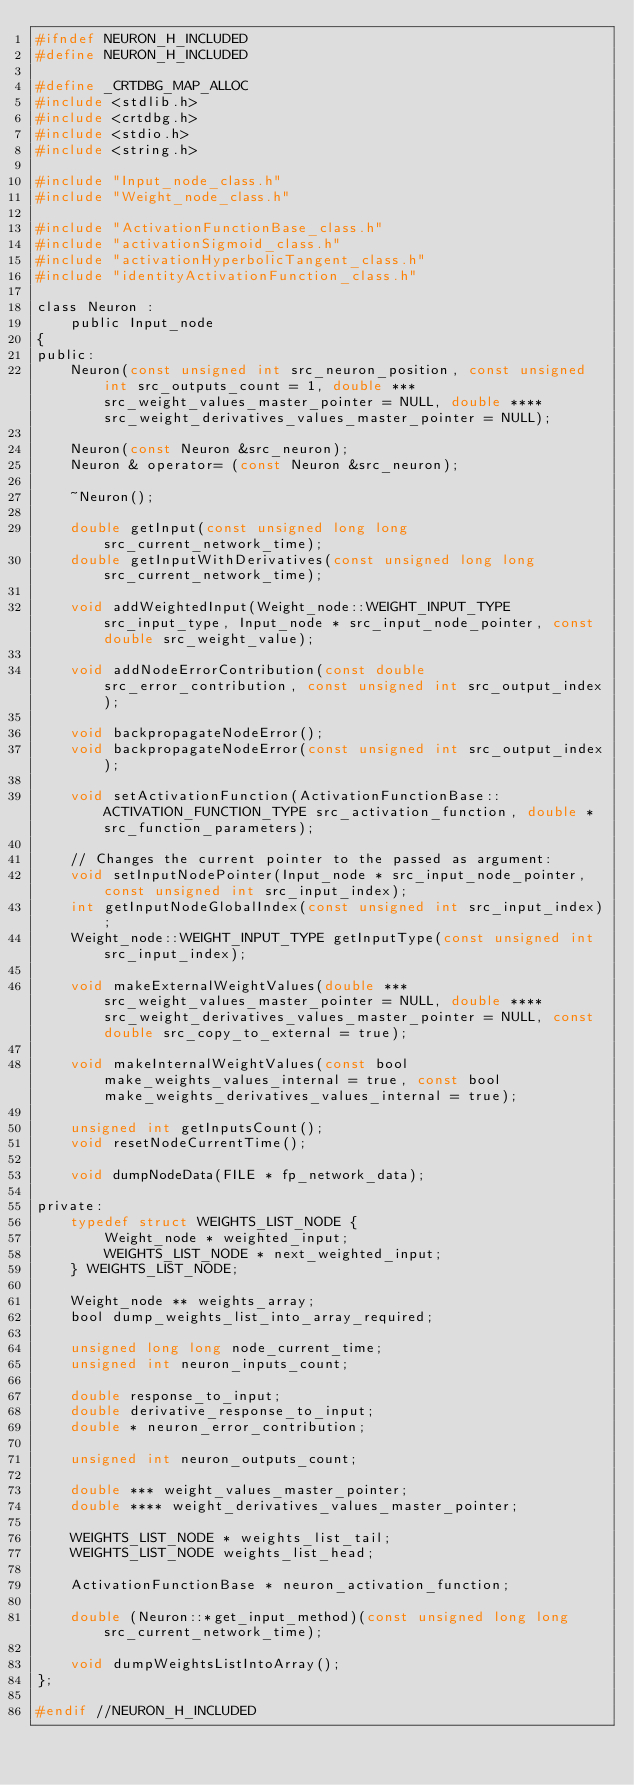<code> <loc_0><loc_0><loc_500><loc_500><_C_>#ifndef NEURON_H_INCLUDED
#define NEURON_H_INCLUDED

#define _CRTDBG_MAP_ALLOC
#include <stdlib.h>
#include <crtdbg.h>
#include <stdio.h>
#include <string.h>

#include "Input_node_class.h"
#include "Weight_node_class.h"

#include "ActivationFunctionBase_class.h"
#include "activationSigmoid_class.h"
#include "activationHyperbolicTangent_class.h"
#include "identityActivationFunction_class.h"

class Neuron :
	public Input_node
{
public:
	Neuron(const unsigned int src_neuron_position, const unsigned int src_outputs_count = 1, double *** src_weight_values_master_pointer = NULL, double **** src_weight_derivatives_values_master_pointer = NULL);

	Neuron(const Neuron &src_neuron);
	Neuron & operator= (const Neuron &src_neuron);

	~Neuron();
	
	double getInput(const unsigned long long src_current_network_time);
	double getInputWithDerivatives(const unsigned long long src_current_network_time);

	void addWeightedInput(Weight_node::WEIGHT_INPUT_TYPE src_input_type, Input_node * src_input_node_pointer, const double src_weight_value);

	void addNodeErrorContribution(const double src_error_contribution, const unsigned int src_output_index);

	void backpropagateNodeError();
	void backpropagateNodeError(const unsigned int src_output_index);

	void setActivationFunction(ActivationFunctionBase::ACTIVATION_FUNCTION_TYPE src_activation_function, double * src_function_parameters);
	
	// Changes the current pointer to the passed as argument:
	void setInputNodePointer(Input_node * src_input_node_pointer, const unsigned int src_input_index);
	int getInputNodeGlobalIndex(const unsigned int src_input_index);
	Weight_node::WEIGHT_INPUT_TYPE getInputType(const unsigned int src_input_index);
	
	void makeExternalWeightValues(double *** src_weight_values_master_pointer = NULL, double **** src_weight_derivatives_values_master_pointer = NULL, const double src_copy_to_external = true);

	void makeInternalWeightValues(const bool make_weights_values_internal = true, const bool make_weights_derivatives_values_internal = true);

	unsigned int getInputsCount();
	void resetNodeCurrentTime();

	void dumpNodeData(FILE * fp_network_data);

private:
	typedef struct WEIGHTS_LIST_NODE {
		Weight_node * weighted_input;
		WEIGHTS_LIST_NODE * next_weighted_input;
	} WEIGHTS_LIST_NODE;
	
	Weight_node ** weights_array;
	bool dump_weights_list_into_array_required;

	unsigned long long node_current_time;
	unsigned int neuron_inputs_count;
	
	double response_to_input;
	double derivative_response_to_input;
	double * neuron_error_contribution;

	unsigned int neuron_outputs_count;

	double *** weight_values_master_pointer;
	double **** weight_derivatives_values_master_pointer;

	WEIGHTS_LIST_NODE * weights_list_tail;
	WEIGHTS_LIST_NODE weights_list_head;

	ActivationFunctionBase * neuron_activation_function;

	double (Neuron::*get_input_method)(const unsigned long long src_current_network_time);
	
	void dumpWeightsListIntoArray();
};

#endif //NEURON_H_INCLUDED

</code> 